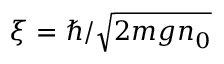<formula> <loc_0><loc_0><loc_500><loc_500>\xi = \hbar { / } \sqrt { 2 m g n _ { 0 } }</formula> 